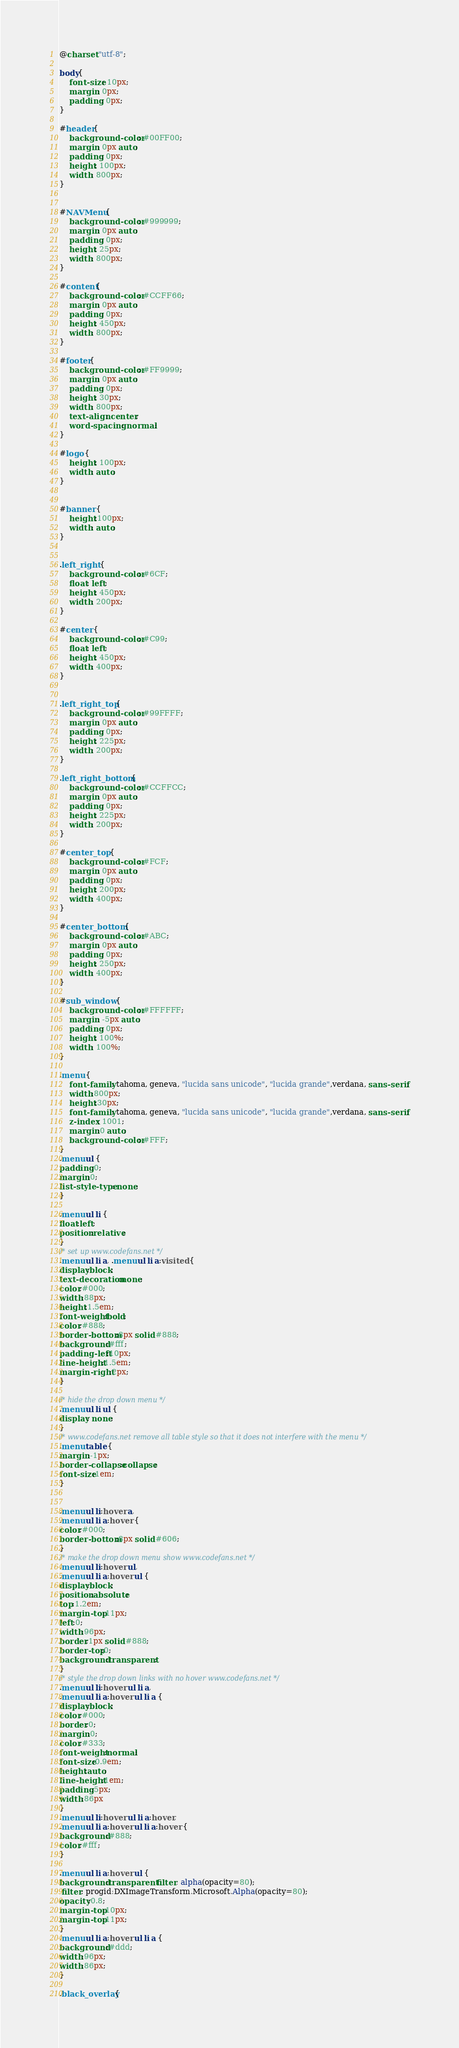<code> <loc_0><loc_0><loc_500><loc_500><_CSS_>@charset "utf-8";

body{
	font-size: 10px;
	margin: 0px;
	padding: 0px;
}

#header{
	background-color: #00FF00;
	margin: 0px auto;
	padding: 0px;
	height: 100px;
	width: 800px;
}


#NAVMenu{
	background-color: #999999;
	margin: 0px auto;
	padding: 0px;
	height: 25px;
	width: 800px;
}

#content{
	background-color: #CCFF66;
	margin: 0px auto;
	padding: 0px;
	height: 450px;
	width: 800px;
}

#footer{
	background-color: #FF9999;
	margin: 0px auto;
	padding: 0px;
	height: 30px;
	width: 800px;
	text-align: center;
	word-spacing: normal;
}

#logo {
	height: 100px;
	width: auto;
}


#banner {
	height:100px;
	width: auto;
}


.left_right {
	background-color: #6CF;
	float: left;
	height: 450px;
	width: 200px;
}

#center {
	background-color: #C99;
	float: left;
	height: 450px;
	width: 400px;
}


.left_right_top {
	background-color: #99FFFF;
	margin: 0px auto;
	padding: 0px;
	height: 225px;
	width: 200px;
}

.left_right_bottom {
	background-color: #CCFFCC;
	margin: 0px auto;
	padding: 0px;
	height: 225px;
	width: 200px;
}

#center_top {
	background-color: #FCF;
	margin: 0px auto;
	padding: 0px;
	height: 200px;
	width: 400px;
}

#center_bottom {
	background-color: #ABC;
	margin: 0px auto;
	padding: 0px;
	height: 250px;
	width: 400px;
}

#sub_window {
	background-color: #FFFFFF;
	margin: -5px auto;
	padding: 0px;
	height: 100%;
	width: 100%;
}

.menu {
	font-family: tahoma, geneva, "lucida sans unicode", "lucida grande",verdana, sans-serif;
	width:800px;
	height:30px;
	font-family: tahoma, geneva, "lucida sans unicode", "lucida grande",verdana, sans-serif;
	z-index: 1001;
	margin:0 auto;
	background-color: #FFF;	
}
.menu ul {
padding:0; 
margin:0;
list-style-type: none;
}

.menu ul li {
float:left;
position:relative;
}
/* set up www.codefans.net */
.menu ul li a, .menu ul li a:visited {
display:block; 
text-decoration:none; 
color:#000; 
width:88px; 
height:1.5em;
font-weight:bold;
color:#888; 
border-bottom:8px solid #888;
background:#fff; 
padding-left:10px; 
line-height:1.5em;
margin-right:2px;
}

/* hide the drop down menu */
.menu ul li ul {
display: none;
}
/* www.codefans.net remove all table style so that it does not interfere with the menu */
.menu table {
margin:-1px; 
border-collapse:collapse;
font-size:1em;
}


.menu ul li:hover a,
.menu ul li a:hover {
color:#000; 
border-bottom:8px solid #606;
}
/* make the drop down menu show www.codefans.net */
.menu ul li:hover ul,
.menu ul li a:hover ul {
display:block; 
position:absolute; 
top:1.2em;
margin-top:11px;
left:0; 
width:96px;
border:1px solid #888;
border-top:0;
background:transparent;
}
/* style the drop down links with no hover www.codefans.net */
.menu ul li:hover ul li a,
.menu ul li a:hover ul li a {
display:block; 
color:#000; 
border:0;
margin:0;
color:#333;
font-weight:normal; 
font-size:0.9em;
height:auto; 
line-height:1em; 
padding:5px; 
width:86px
}
.menu ul li:hover ul li a:hover,
.menu ul li a:hover ul li a:hover {
background:#888; 
color:#fff;
}

.menu ul li a:hover ul {
background:transparent filter: alpha(opacity=80);
 filter: progid:DXImageTransform.Microsoft.Alpha(opacity=80);
opacity:0.8;
margin-top:10px; 
margin-top:11px; 
}
.menu ul li a:hover ul li a {
background:#ddd;
width:96px;
width:86px;
}

.black_overlay{ </code> 